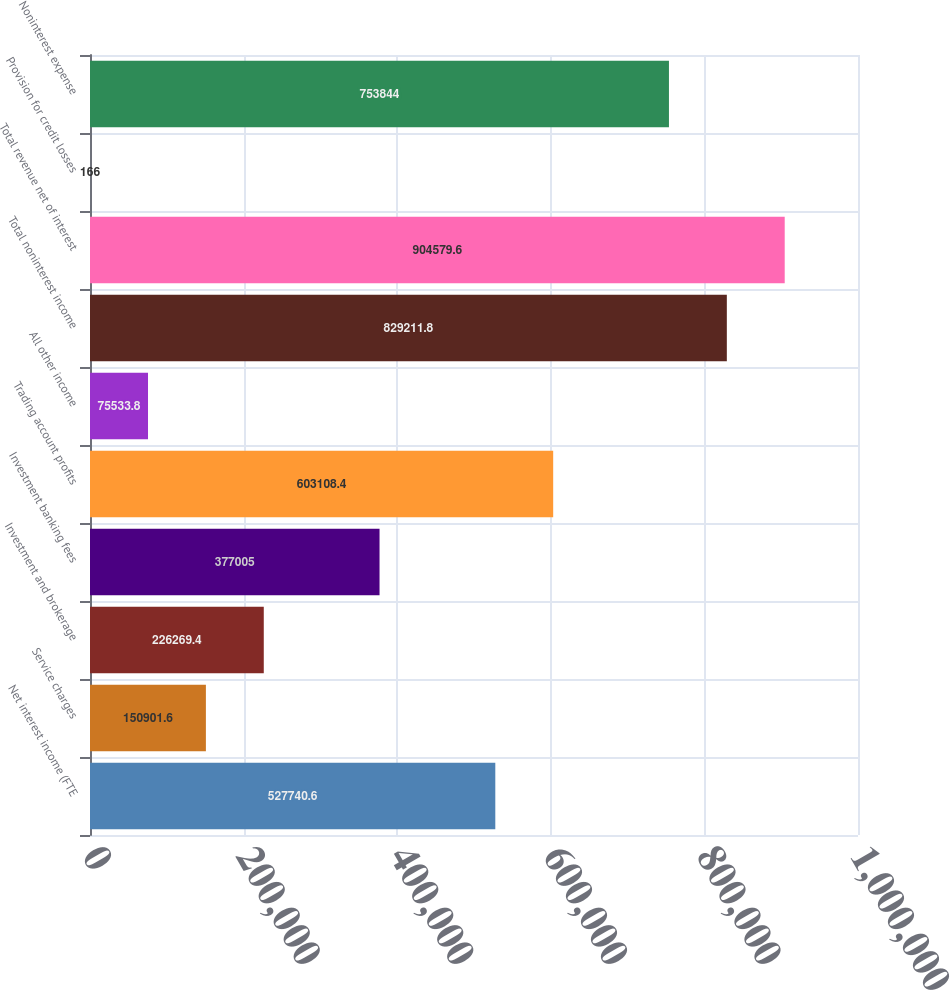<chart> <loc_0><loc_0><loc_500><loc_500><bar_chart><fcel>Net interest income (FTE<fcel>Service charges<fcel>Investment and brokerage<fcel>Investment banking fees<fcel>Trading account profits<fcel>All other income<fcel>Total noninterest income<fcel>Total revenue net of interest<fcel>Provision for credit losses<fcel>Noninterest expense<nl><fcel>527741<fcel>150902<fcel>226269<fcel>377005<fcel>603108<fcel>75533.8<fcel>829212<fcel>904580<fcel>166<fcel>753844<nl></chart> 